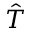<formula> <loc_0><loc_0><loc_500><loc_500>\hat { T }</formula> 